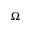<formula> <loc_0><loc_0><loc_500><loc_500>\Omega</formula> 